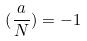Convert formula to latex. <formula><loc_0><loc_0><loc_500><loc_500>( \frac { a } { N } ) = - 1</formula> 